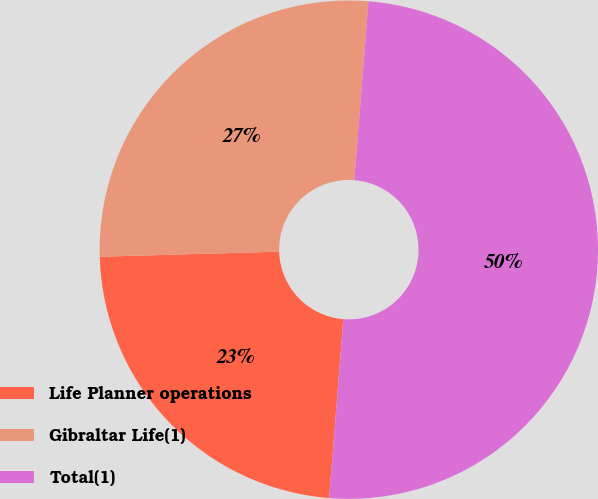Convert chart to OTSL. <chart><loc_0><loc_0><loc_500><loc_500><pie_chart><fcel>Life Planner operations<fcel>Gibraltar Life(1)<fcel>Total(1)<nl><fcel>23.29%<fcel>26.71%<fcel>50.0%<nl></chart> 